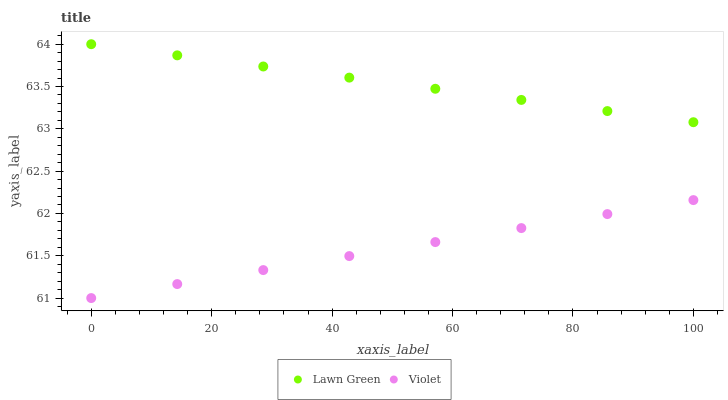Does Violet have the minimum area under the curve?
Answer yes or no. Yes. Does Lawn Green have the maximum area under the curve?
Answer yes or no. Yes. Does Violet have the maximum area under the curve?
Answer yes or no. No. Is Lawn Green the smoothest?
Answer yes or no. Yes. Is Violet the roughest?
Answer yes or no. Yes. Is Violet the smoothest?
Answer yes or no. No. Does Violet have the lowest value?
Answer yes or no. Yes. Does Lawn Green have the highest value?
Answer yes or no. Yes. Does Violet have the highest value?
Answer yes or no. No. Is Violet less than Lawn Green?
Answer yes or no. Yes. Is Lawn Green greater than Violet?
Answer yes or no. Yes. Does Violet intersect Lawn Green?
Answer yes or no. No. 